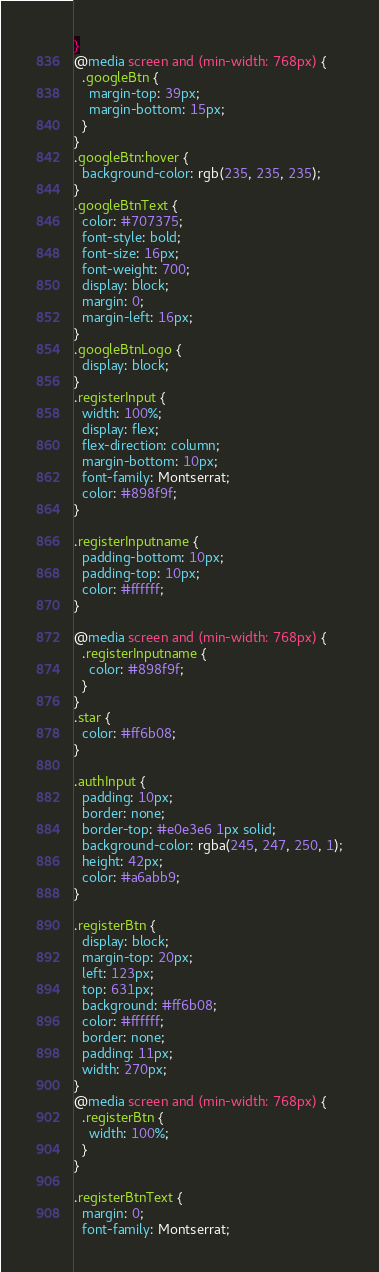Convert code to text. <code><loc_0><loc_0><loc_500><loc_500><_CSS_>}
@media screen and (min-width: 768px) {
  .googleBtn {
    margin-top: 39px;
    margin-bottom: 15px;
  }
}
.googleBtn:hover {
  background-color: rgb(235, 235, 235);
}
.googleBtnText {
  color: #707375;
  font-style: bold;
  font-size: 16px;
  font-weight: 700;
  display: block;
  margin: 0;
  margin-left: 16px;
}
.googleBtnLogo {
  display: block;
}
.registerInput {
  width: 100%;
  display: flex;
  flex-direction: column;
  margin-bottom: 10px;
  font-family: Montserrat;
  color: #898f9f;
}

.registerInputname {
  padding-bottom: 10px;
  padding-top: 10px;
  color: #ffffff;
}

@media screen and (min-width: 768px) {
  .registerInputname {
    color: #898f9f;
  }
}
.star {
  color: #ff6b08;
}

.authInput {
  padding: 10px;
  border: none;
  border-top: #e0e3e6 1px solid;
  background-color: rgba(245, 247, 250, 1);
  height: 42px;
  color: #a6abb9;
}

.registerBtn {
  display: block;
  margin-top: 20px;
  left: 123px;
  top: 631px;
  background: #ff6b08;
  color: #ffffff;
  border: none;
  padding: 11px;
  width: 270px;
}
@media screen and (min-width: 768px) {
  .registerBtn {
    width: 100%;
  }
}

.registerBtnText {
  margin: 0;
  font-family: Montserrat;</code> 